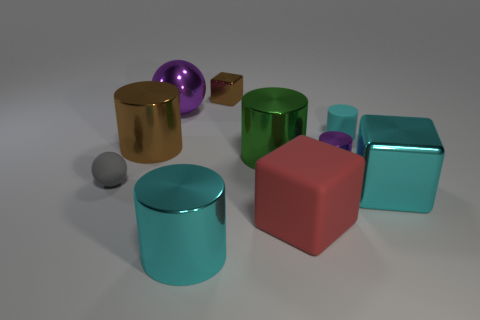There is a tiny gray thing; is it the same shape as the cyan thing that is in front of the big cyan cube? The tiny gray object appears to be spherical, which is not the same shape as the cyan object in front of the large cyan cube. The cyan object has distinctly flat surfaces and sharp edges, indicating that it is a polyhedral shape, likely a smaller cube. Therefore, their shapes are different; one is spherical, and the other is cuboidal. 